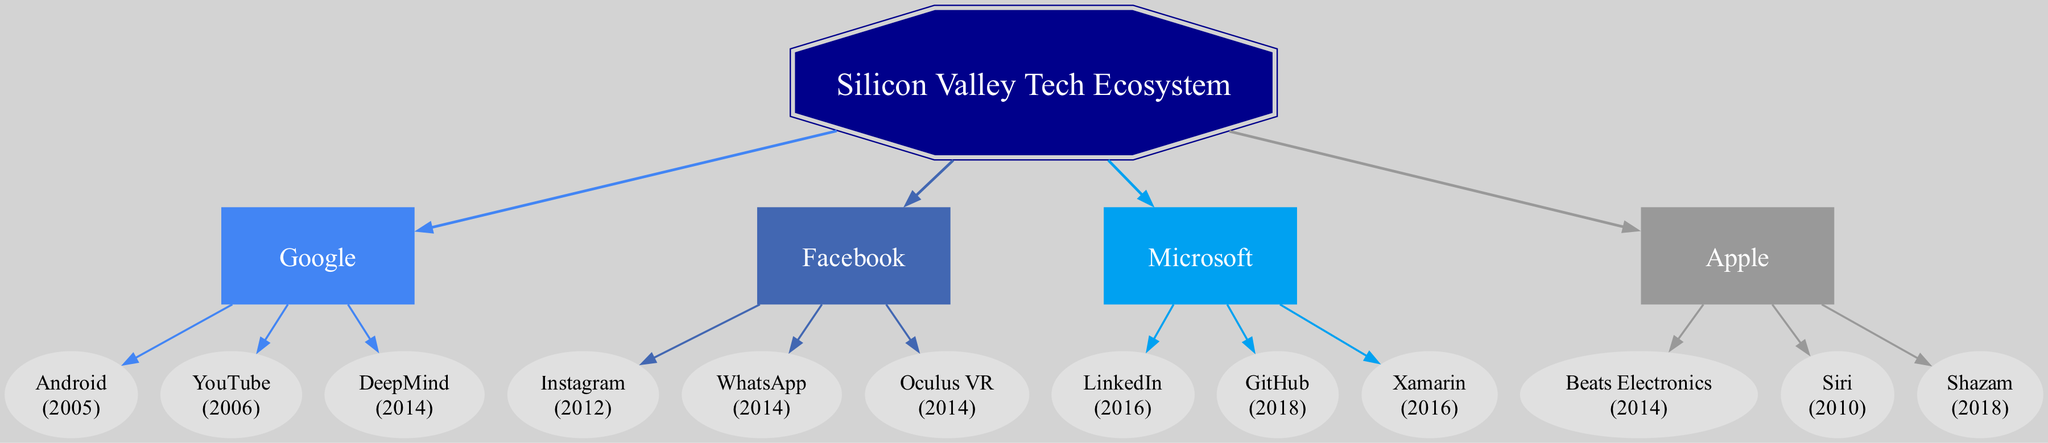What are the three companies under Google? To answer this question, we refer to the "children" section under the "Google" node in the diagram. The companies listed are Android, YouTube, and DeepMind.
Answer: Android, YouTube, DeepMind How many acquisitions did Facebook make? By counting the number of child nodes listed under the "Facebook" node, we see that there are three acquisitions: Instagram, WhatsApp, and Oculus VR.
Answer: 3 What year did Apple acquire Beats Electronics? Looking at the child nodes under "Apple," we find the acquisition year for Beats Electronics mentioned as 2014.
Answer: 2014 Which company acquired LinkedIn? Examining the "children" section under "Microsoft," we note that LinkedIn is listed as one of its acquisitions. Thus, Microsoft is the company that acquired LinkedIn.
Answer: Microsoft Which acquisition did happen in the same year as WhatsApp? By checking the acquisition years listed for each company, we see that both WhatsApp and Oculus VR were acquired in 2014. Thus, Oculus VR is the other acquisition in that year.
Answer: Oculus VR What is the acquisition sequence for companies owned by Facebook? To determine the acquisition sequence, we must check the order of the acquisitions under the "Facebook" node based on their year of acquisition. The timeline shows that Instagram was acquired in 2012, followed by WhatsApp and Oculus VR in 2014.
Answer: Instagram, WhatsApp, Oculus VR Which company had the earliest acquisition in this diagram? By examining the acquisition years of all companies present in the diagram, we note that Android was acquired in 2005, which is the earliest year.
Answer: Android How many children does Microsoft have in the diagram? By counting the number of child nodes listed under the "Microsoft" node, we find that it has three children: LinkedIn, GitHub, and Xamarin.
Answer: 3 What color is used for Google's node? Referring to the "colors" palette used in the graph, the color assigned to Google's node is a specific shade of blue, represented by the hexadecimal code #4285F4.
Answer: #4285F4 